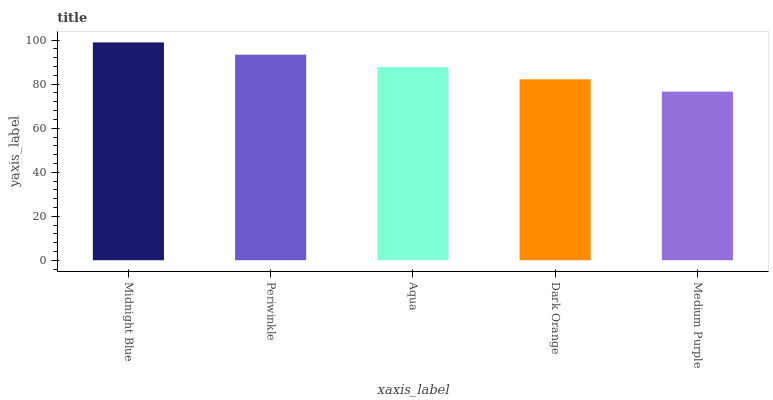Is Medium Purple the minimum?
Answer yes or no. Yes. Is Midnight Blue the maximum?
Answer yes or no. Yes. Is Periwinkle the minimum?
Answer yes or no. No. Is Periwinkle the maximum?
Answer yes or no. No. Is Midnight Blue greater than Periwinkle?
Answer yes or no. Yes. Is Periwinkle less than Midnight Blue?
Answer yes or no. Yes. Is Periwinkle greater than Midnight Blue?
Answer yes or no. No. Is Midnight Blue less than Periwinkle?
Answer yes or no. No. Is Aqua the high median?
Answer yes or no. Yes. Is Aqua the low median?
Answer yes or no. Yes. Is Midnight Blue the high median?
Answer yes or no. No. Is Dark Orange the low median?
Answer yes or no. No. 